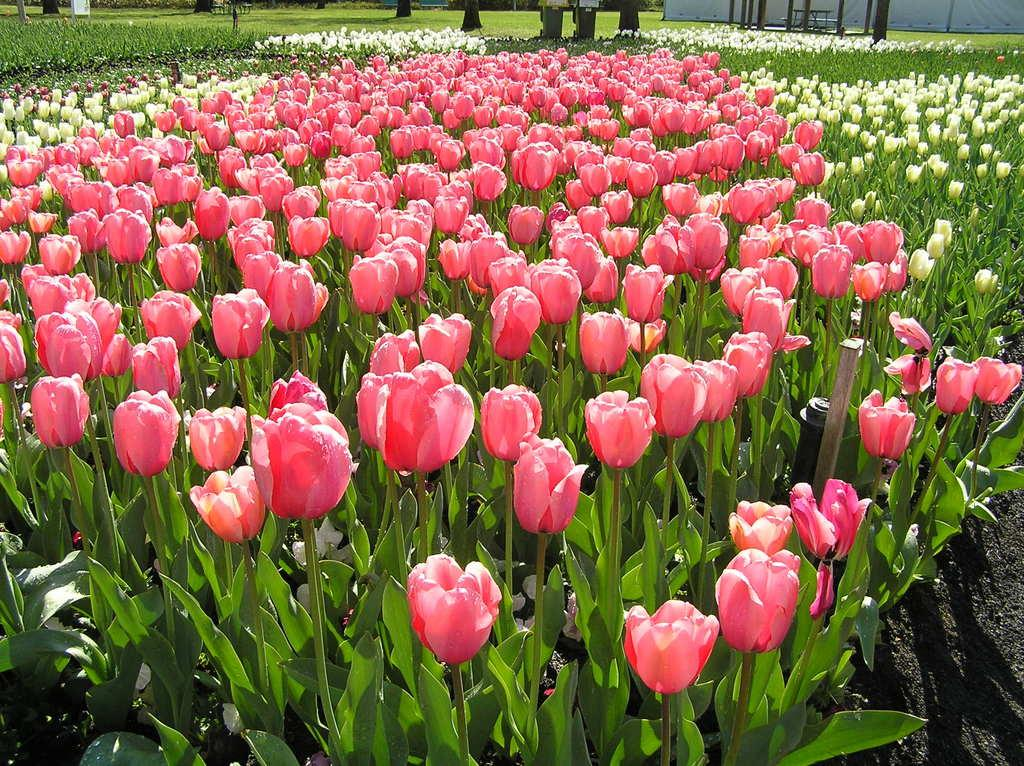What type of plants can be seen in the image? There are plants with different colored flowers in the image. What part of the plants is visible in the image? Tree trunks are visible at the top of the image. What other objects can be seen on the grassland in the image? There are poles on the grassland in the image. What structure is visible on the right top of the image? There is a wall on the right top of the image. What type of story is being told by the tree in the image? There is no tree present in the image, so no story can be told by a tree. 